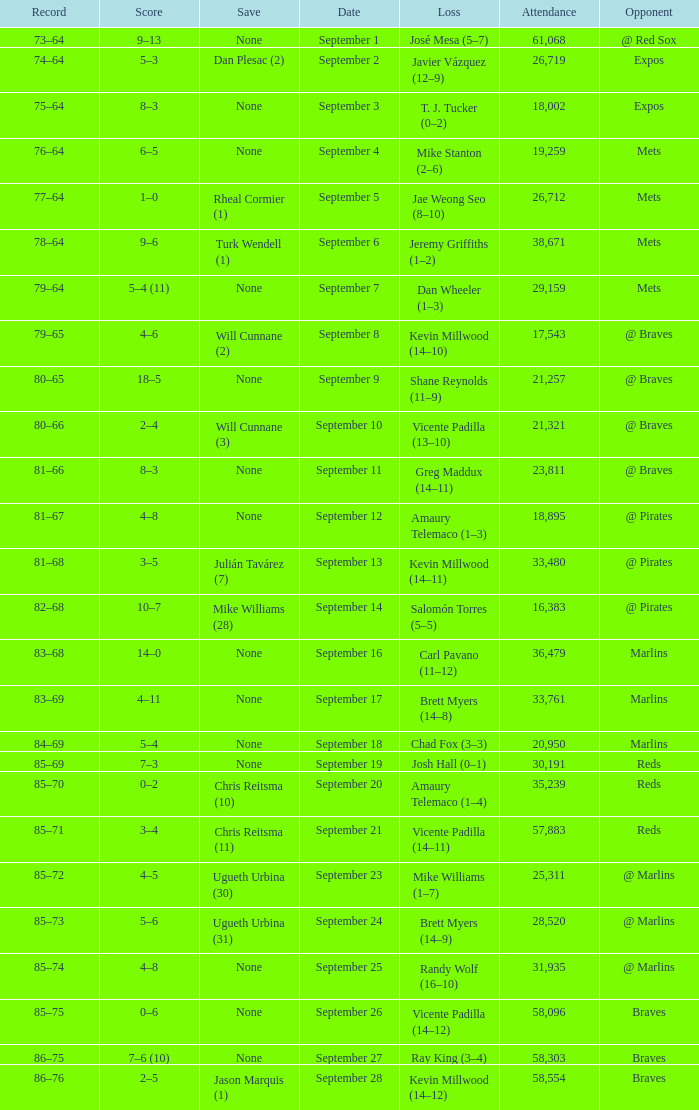What was the attendance at game with a loss of Josh Hall (0–1)? 30191.0. 